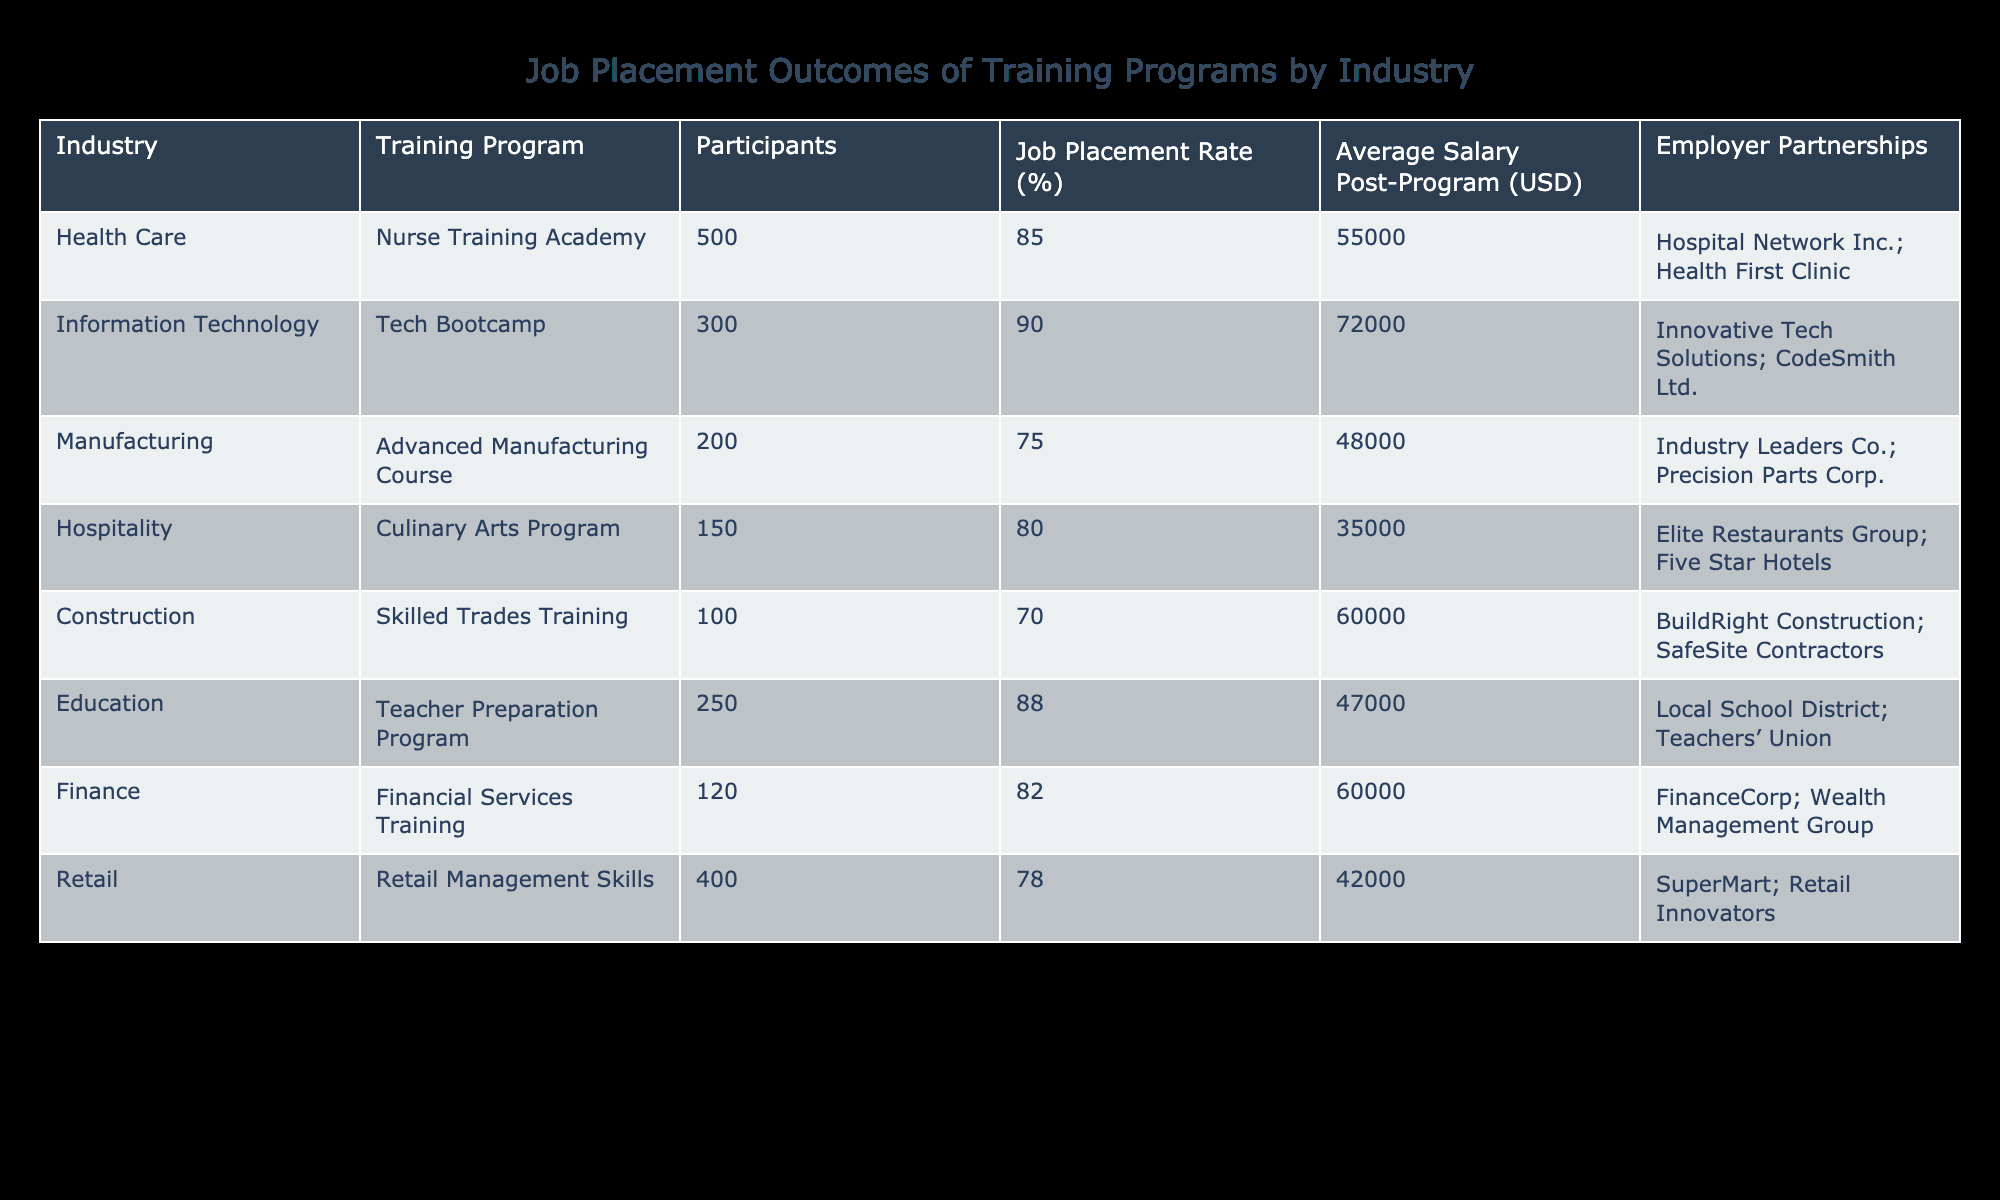What is the job placement rate for the Nurse Training Academy? The table shows the job placement rate for the Nurse Training Academy in the column labeled "Job Placement Rate (%)". It is listed as 85%.
Answer: 85% Which training program has the highest average salary post-program? By inspecting the "Average Salary Post-Program (USD)" column, the Tech Bootcamp shows the highest salary at 72000 USD.
Answer: Tech Bootcamp Is the job placement rate for the Manufacturing training program greater than 75%? From the table, the job placement rate for the Advanced Manufacturing Course is 75%, which is not greater than 75%. Hence, the answer is false.
Answer: No Calculate the average job placement rate for all training programs listed. To find the average, we add all the job placement rates: 85 + 90 + 75 + 80 + 70 + 88 + 82 + 78 =  598. Next, divide by the number of training programs, which is 8. Therefore, 598/8 = 74.75%.
Answer: 74.75% Which industry has the lowest job placement rate and what is that rate? By scanning the "Job Placement Rate (%)" column, the lowest rate found is for the Skilled Trades Training in the Construction industry, which is 70%.
Answer: Construction, 70% Do any of the training programs provide wage information greater than $60,000 post-program? Checking the "Average Salary Post-Program (USD)" column, both the Tech Bootcamp (72000 USD) and Skilled Trades Training (60000 USD) have salaries over $60,000, making the answer true.
Answer: Yes What percentage of participants in the Hospitality training program were successfully placed in jobs? The job placement rate for the Culinary Arts Program in the Hospitality industry is directly listed as 80%.
Answer: 80% Calculate the difference in job placement rates between the Education and Finance training programs. For the Education program, the job placement rate is 88%, and for the Finance program, it is 82%. The difference is calculated as 88 - 82 = 6%.
Answer: 6% 